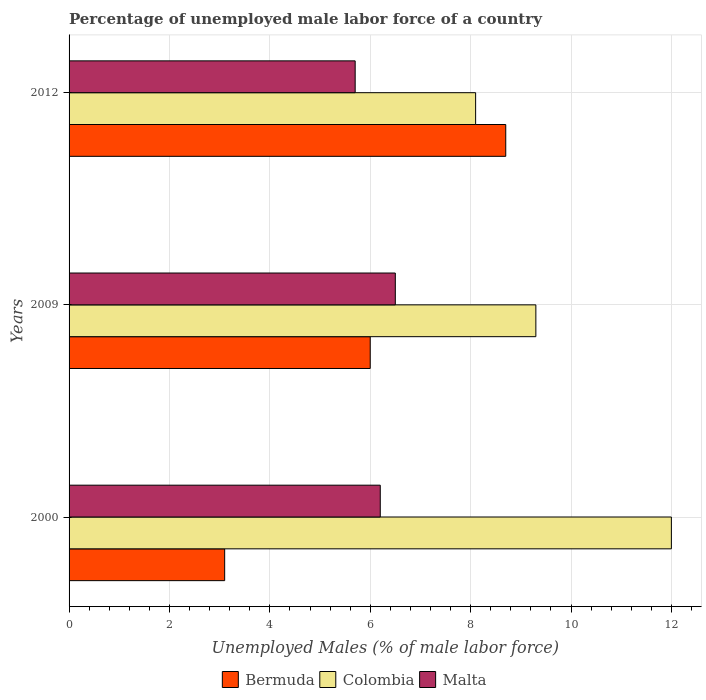How many different coloured bars are there?
Keep it short and to the point. 3. How many groups of bars are there?
Provide a short and direct response. 3. How many bars are there on the 3rd tick from the bottom?
Give a very brief answer. 3. In how many cases, is the number of bars for a given year not equal to the number of legend labels?
Provide a short and direct response. 0. What is the percentage of unemployed male labor force in Malta in 2000?
Provide a short and direct response. 6.2. Across all years, what is the maximum percentage of unemployed male labor force in Bermuda?
Your response must be concise. 8.7. Across all years, what is the minimum percentage of unemployed male labor force in Malta?
Offer a very short reply. 5.7. What is the total percentage of unemployed male labor force in Bermuda in the graph?
Your answer should be very brief. 17.8. What is the difference between the percentage of unemployed male labor force in Bermuda in 2000 and that in 2012?
Your answer should be compact. -5.6. What is the difference between the percentage of unemployed male labor force in Colombia in 2000 and the percentage of unemployed male labor force in Malta in 2012?
Your answer should be very brief. 6.3. What is the average percentage of unemployed male labor force in Bermuda per year?
Your answer should be compact. 5.93. In the year 2012, what is the difference between the percentage of unemployed male labor force in Colombia and percentage of unemployed male labor force in Bermuda?
Offer a very short reply. -0.6. In how many years, is the percentage of unemployed male labor force in Bermuda greater than 10 %?
Your response must be concise. 0. What is the ratio of the percentage of unemployed male labor force in Colombia in 2000 to that in 2012?
Provide a succinct answer. 1.48. Is the percentage of unemployed male labor force in Bermuda in 2000 less than that in 2012?
Your response must be concise. Yes. What is the difference between the highest and the second highest percentage of unemployed male labor force in Colombia?
Your response must be concise. 2.7. What is the difference between the highest and the lowest percentage of unemployed male labor force in Bermuda?
Your answer should be very brief. 5.6. In how many years, is the percentage of unemployed male labor force in Bermuda greater than the average percentage of unemployed male labor force in Bermuda taken over all years?
Give a very brief answer. 2. What does the 1st bar from the top in 2012 represents?
Offer a terse response. Malta. What does the 3rd bar from the bottom in 2012 represents?
Offer a very short reply. Malta. Are the values on the major ticks of X-axis written in scientific E-notation?
Your answer should be very brief. No. Does the graph contain any zero values?
Offer a very short reply. No. Does the graph contain grids?
Ensure brevity in your answer.  Yes. What is the title of the graph?
Your answer should be compact. Percentage of unemployed male labor force of a country. Does "American Samoa" appear as one of the legend labels in the graph?
Offer a terse response. No. What is the label or title of the X-axis?
Provide a short and direct response. Unemployed Males (% of male labor force). What is the Unemployed Males (% of male labor force) of Bermuda in 2000?
Offer a terse response. 3.1. What is the Unemployed Males (% of male labor force) in Malta in 2000?
Ensure brevity in your answer.  6.2. What is the Unemployed Males (% of male labor force) of Colombia in 2009?
Your answer should be very brief. 9.3. What is the Unemployed Males (% of male labor force) in Bermuda in 2012?
Keep it short and to the point. 8.7. What is the Unemployed Males (% of male labor force) in Colombia in 2012?
Provide a short and direct response. 8.1. What is the Unemployed Males (% of male labor force) of Malta in 2012?
Give a very brief answer. 5.7. Across all years, what is the maximum Unemployed Males (% of male labor force) in Bermuda?
Offer a very short reply. 8.7. Across all years, what is the maximum Unemployed Males (% of male labor force) of Colombia?
Your answer should be compact. 12. Across all years, what is the maximum Unemployed Males (% of male labor force) in Malta?
Provide a short and direct response. 6.5. Across all years, what is the minimum Unemployed Males (% of male labor force) of Bermuda?
Ensure brevity in your answer.  3.1. Across all years, what is the minimum Unemployed Males (% of male labor force) of Colombia?
Keep it short and to the point. 8.1. Across all years, what is the minimum Unemployed Males (% of male labor force) in Malta?
Keep it short and to the point. 5.7. What is the total Unemployed Males (% of male labor force) of Bermuda in the graph?
Keep it short and to the point. 17.8. What is the total Unemployed Males (% of male labor force) in Colombia in the graph?
Offer a very short reply. 29.4. What is the total Unemployed Males (% of male labor force) of Malta in the graph?
Provide a short and direct response. 18.4. What is the difference between the Unemployed Males (% of male labor force) in Bermuda in 2000 and that in 2009?
Your answer should be compact. -2.9. What is the difference between the Unemployed Males (% of male labor force) in Colombia in 2000 and that in 2009?
Offer a very short reply. 2.7. What is the difference between the Unemployed Males (% of male labor force) of Malta in 2000 and that in 2009?
Offer a very short reply. -0.3. What is the difference between the Unemployed Males (% of male labor force) in Bermuda in 2000 and that in 2012?
Provide a succinct answer. -5.6. What is the difference between the Unemployed Males (% of male labor force) of Bermuda in 2009 and that in 2012?
Ensure brevity in your answer.  -2.7. What is the difference between the Unemployed Males (% of male labor force) of Colombia in 2009 and that in 2012?
Your response must be concise. 1.2. What is the difference between the Unemployed Males (% of male labor force) in Malta in 2009 and that in 2012?
Your answer should be very brief. 0.8. What is the difference between the Unemployed Males (% of male labor force) of Bermuda in 2000 and the Unemployed Males (% of male labor force) of Malta in 2009?
Provide a short and direct response. -3.4. What is the difference between the Unemployed Males (% of male labor force) in Bermuda in 2000 and the Unemployed Males (% of male labor force) in Malta in 2012?
Provide a short and direct response. -2.6. What is the difference between the Unemployed Males (% of male labor force) of Bermuda in 2009 and the Unemployed Males (% of male labor force) of Colombia in 2012?
Provide a short and direct response. -2.1. What is the difference between the Unemployed Males (% of male labor force) in Bermuda in 2009 and the Unemployed Males (% of male labor force) in Malta in 2012?
Provide a succinct answer. 0.3. What is the difference between the Unemployed Males (% of male labor force) of Colombia in 2009 and the Unemployed Males (% of male labor force) of Malta in 2012?
Offer a terse response. 3.6. What is the average Unemployed Males (% of male labor force) of Bermuda per year?
Provide a succinct answer. 5.93. What is the average Unemployed Males (% of male labor force) of Malta per year?
Make the answer very short. 6.13. In the year 2000, what is the difference between the Unemployed Males (% of male labor force) of Bermuda and Unemployed Males (% of male labor force) of Malta?
Provide a succinct answer. -3.1. In the year 2009, what is the difference between the Unemployed Males (% of male labor force) of Bermuda and Unemployed Males (% of male labor force) of Colombia?
Make the answer very short. -3.3. In the year 2009, what is the difference between the Unemployed Males (% of male labor force) of Bermuda and Unemployed Males (% of male labor force) of Malta?
Ensure brevity in your answer.  -0.5. In the year 2012, what is the difference between the Unemployed Males (% of male labor force) in Bermuda and Unemployed Males (% of male labor force) in Colombia?
Your response must be concise. 0.6. In the year 2012, what is the difference between the Unemployed Males (% of male labor force) in Bermuda and Unemployed Males (% of male labor force) in Malta?
Keep it short and to the point. 3. In the year 2012, what is the difference between the Unemployed Males (% of male labor force) in Colombia and Unemployed Males (% of male labor force) in Malta?
Give a very brief answer. 2.4. What is the ratio of the Unemployed Males (% of male labor force) of Bermuda in 2000 to that in 2009?
Ensure brevity in your answer.  0.52. What is the ratio of the Unemployed Males (% of male labor force) in Colombia in 2000 to that in 2009?
Provide a short and direct response. 1.29. What is the ratio of the Unemployed Males (% of male labor force) of Malta in 2000 to that in 2009?
Give a very brief answer. 0.95. What is the ratio of the Unemployed Males (% of male labor force) of Bermuda in 2000 to that in 2012?
Your response must be concise. 0.36. What is the ratio of the Unemployed Males (% of male labor force) of Colombia in 2000 to that in 2012?
Provide a short and direct response. 1.48. What is the ratio of the Unemployed Males (% of male labor force) of Malta in 2000 to that in 2012?
Provide a succinct answer. 1.09. What is the ratio of the Unemployed Males (% of male labor force) in Bermuda in 2009 to that in 2012?
Your answer should be very brief. 0.69. What is the ratio of the Unemployed Males (% of male labor force) of Colombia in 2009 to that in 2012?
Make the answer very short. 1.15. What is the ratio of the Unemployed Males (% of male labor force) in Malta in 2009 to that in 2012?
Your answer should be compact. 1.14. What is the difference between the highest and the second highest Unemployed Males (% of male labor force) in Bermuda?
Make the answer very short. 2.7. What is the difference between the highest and the second highest Unemployed Males (% of male labor force) of Malta?
Ensure brevity in your answer.  0.3. What is the difference between the highest and the lowest Unemployed Males (% of male labor force) of Bermuda?
Make the answer very short. 5.6. What is the difference between the highest and the lowest Unemployed Males (% of male labor force) in Malta?
Provide a short and direct response. 0.8. 